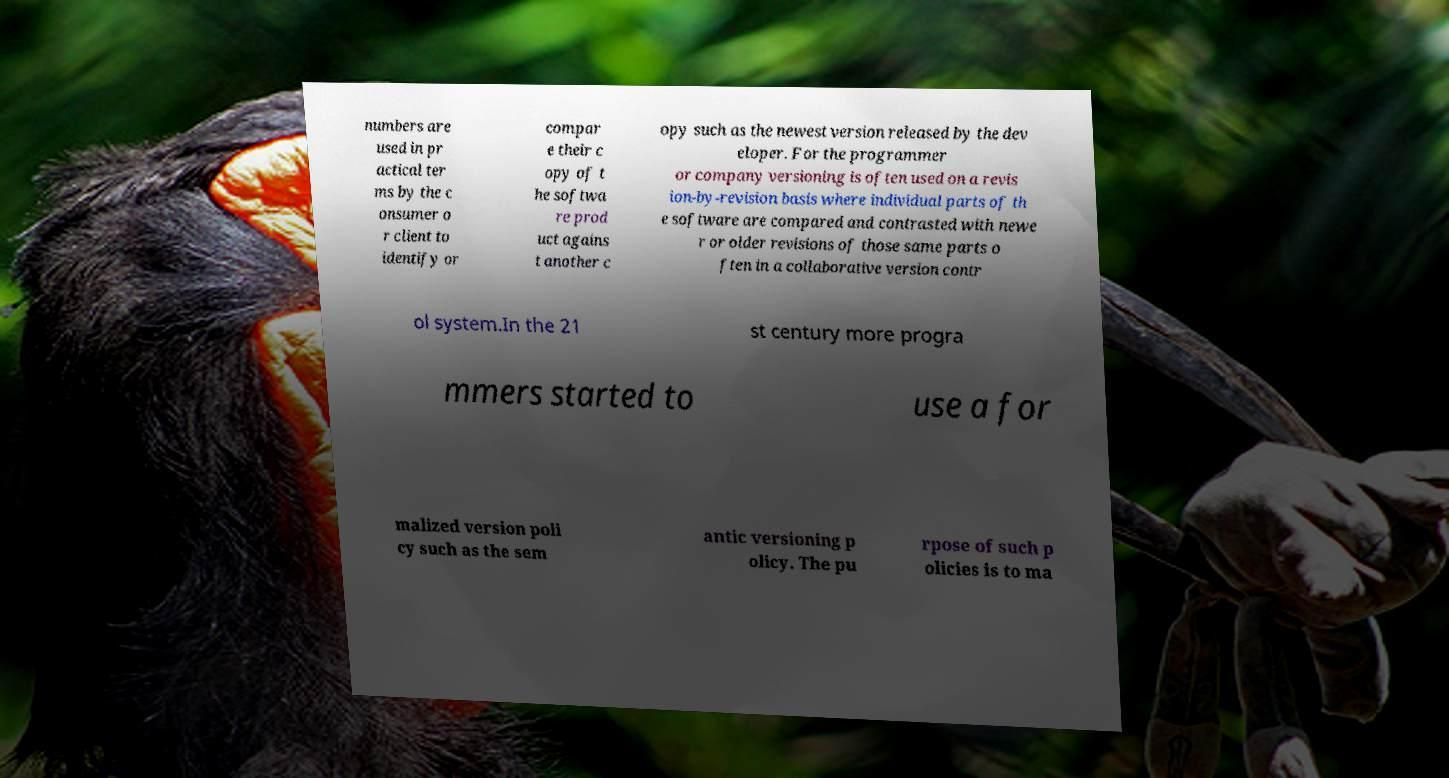Can you accurately transcribe the text from the provided image for me? numbers are used in pr actical ter ms by the c onsumer o r client to identify or compar e their c opy of t he softwa re prod uct agains t another c opy such as the newest version released by the dev eloper. For the programmer or company versioning is often used on a revis ion-by-revision basis where individual parts of th e software are compared and contrasted with newe r or older revisions of those same parts o ften in a collaborative version contr ol system.In the 21 st century more progra mmers started to use a for malized version poli cy such as the sem antic versioning p olicy. The pu rpose of such p olicies is to ma 